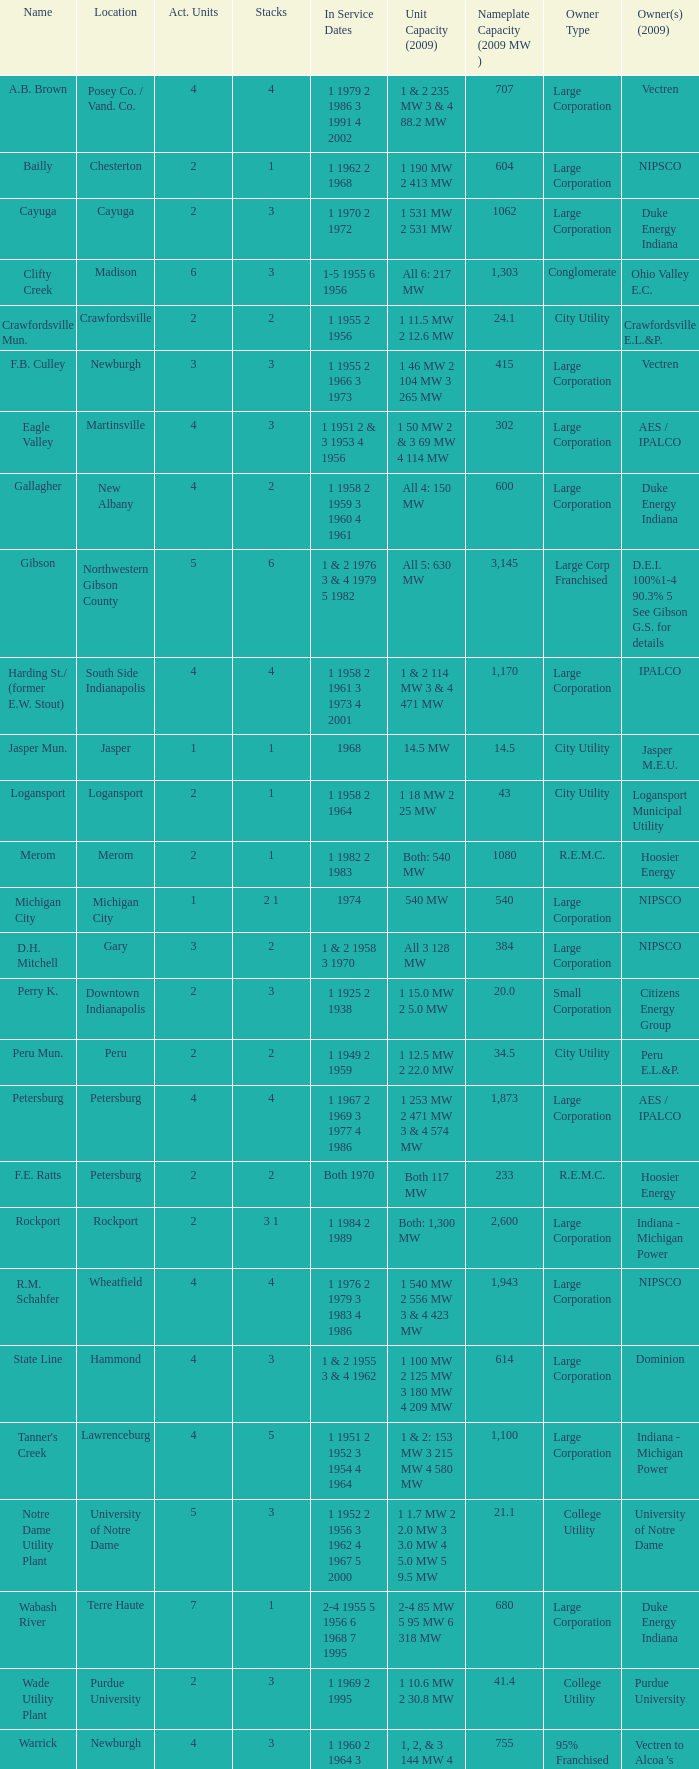Identify the count of stacks for 1 & 2 having 235 mw and 3 & 4 with 88.2 mw capacity. 1.0. Parse the full table. {'header': ['Name', 'Location', 'Act. Units', 'Stacks', 'In Service Dates', 'Unit Capacity (2009)', 'Nameplate Capacity (2009 MW )', 'Owner Type', 'Owner(s) (2009)'], 'rows': [['A.B. Brown', 'Posey Co. / Vand. Co.', '4', '4', '1 1979 2 1986 3 1991 4 2002', '1 & 2 235 MW 3 & 4 88.2 MW', '707', 'Large Corporation', 'Vectren'], ['Bailly', 'Chesterton', '2', '1', '1 1962 2 1968', '1 190 MW 2 413 MW', '604', 'Large Corporation', 'NIPSCO'], ['Cayuga', 'Cayuga', '2', '3', '1 1970 2 1972', '1 531 MW 2 531 MW', '1062', 'Large Corporation', 'Duke Energy Indiana'], ['Clifty Creek', 'Madison', '6', '3', '1-5 1955 6 1956', 'All 6: 217 MW', '1,303', 'Conglomerate', 'Ohio Valley E.C.'], ['Crawfordsville Mun.', 'Crawfordsville', '2', '2', '1 1955 2 1956', '1 11.5 MW 2 12.6 MW', '24.1', 'City Utility', 'Crawfordsville E.L.&P.'], ['F.B. Culley', 'Newburgh', '3', '3', '1 1955 2 1966 3 1973', '1 46 MW 2 104 MW 3 265 MW', '415', 'Large Corporation', 'Vectren'], ['Eagle Valley', 'Martinsville', '4', '3', '1 1951 2 & 3 1953 4 1956', '1 50 MW 2 & 3 69 MW 4 114 MW', '302', 'Large Corporation', 'AES / IPALCO'], ['Gallagher', 'New Albany', '4', '2', '1 1958 2 1959 3 1960 4 1961', 'All 4: 150 MW', '600', 'Large Corporation', 'Duke Energy Indiana'], ['Gibson', 'Northwestern Gibson County', '5', '6', '1 & 2 1976 3 & 4 1979 5 1982', 'All 5: 630 MW', '3,145', 'Large Corp Franchised', 'D.E.I. 100%1-4 90.3% 5 See Gibson G.S. for details'], ['Harding St./ (former E.W. Stout)', 'South Side Indianapolis', '4', '4', '1 1958 2 1961 3 1973 4 2001', '1 & 2 114 MW 3 & 4 471 MW', '1,170', 'Large Corporation', 'IPALCO'], ['Jasper Mun.', 'Jasper', '1', '1', '1968', '14.5 MW', '14.5', 'City Utility', 'Jasper M.E.U.'], ['Logansport', 'Logansport', '2', '1', '1 1958 2 1964', '1 18 MW 2 25 MW', '43', 'City Utility', 'Logansport Municipal Utility'], ['Merom', 'Merom', '2', '1', '1 1982 2 1983', 'Both: 540 MW', '1080', 'R.E.M.C.', 'Hoosier Energy'], ['Michigan City', 'Michigan City', '1', '2 1', '1974', '540 MW', '540', 'Large Corporation', 'NIPSCO'], ['D.H. Mitchell', 'Gary', '3', '2', '1 & 2 1958 3 1970', 'All 3 128 MW', '384', 'Large Corporation', 'NIPSCO'], ['Perry K.', 'Downtown Indianapolis', '2', '3', '1 1925 2 1938', '1 15.0 MW 2 5.0 MW', '20.0', 'Small Corporation', 'Citizens Energy Group'], ['Peru Mun.', 'Peru', '2', '2', '1 1949 2 1959', '1 12.5 MW 2 22.0 MW', '34.5', 'City Utility', 'Peru E.L.&P.'], ['Petersburg', 'Petersburg', '4', '4', '1 1967 2 1969 3 1977 4 1986', '1 253 MW 2 471 MW 3 & 4 574 MW', '1,873', 'Large Corporation', 'AES / IPALCO'], ['F.E. Ratts', 'Petersburg', '2', '2', 'Both 1970', 'Both 117 MW', '233', 'R.E.M.C.', 'Hoosier Energy'], ['Rockport', 'Rockport', '2', '3 1', '1 1984 2 1989', 'Both: 1,300 MW', '2,600', 'Large Corporation', 'Indiana - Michigan Power'], ['R.M. Schahfer', 'Wheatfield', '4', '4', '1 1976 2 1979 3 1983 4 1986', '1 540 MW 2 556 MW 3 & 4 423 MW', '1,943', 'Large Corporation', 'NIPSCO'], ['State Line', 'Hammond', '4', '3', '1 & 2 1955 3 & 4 1962', '1 100 MW 2 125 MW 3 180 MW 4 209 MW', '614', 'Large Corporation', 'Dominion'], ["Tanner's Creek", 'Lawrenceburg', '4', '5', '1 1951 2 1952 3 1954 4 1964', '1 & 2: 153 MW 3 215 MW 4 580 MW', '1,100', 'Large Corporation', 'Indiana - Michigan Power'], ['Notre Dame Utility Plant', 'University of Notre Dame', '5', '3', '1 1952 2 1956 3 1962 4 1967 5 2000', '1 1.7 MW 2 2.0 MW 3 3.0 MW 4 5.0 MW 5 9.5 MW', '21.1', 'College Utility', 'University of Notre Dame'], ['Wabash River', 'Terre Haute', '7', '1', '2-4 1955 5 1956 6 1968 7 1995', '2-4 85 MW 5 95 MW 6 318 MW', '680', 'Large Corporation', 'Duke Energy Indiana'], ['Wade Utility Plant', 'Purdue University', '2', '3', '1 1969 2 1995', '1 10.6 MW 2 30.8 MW', '41.4', 'College Utility', 'Purdue University'], ['Warrick', 'Newburgh', '4', '3', '1 1960 2 1964 3 1965 4 1970', '1, 2, & 3 144 MW 4 323 MW', '755', '95% Franchised', "Vectren to Alcoa 's Newburgh Smelter"]]} 